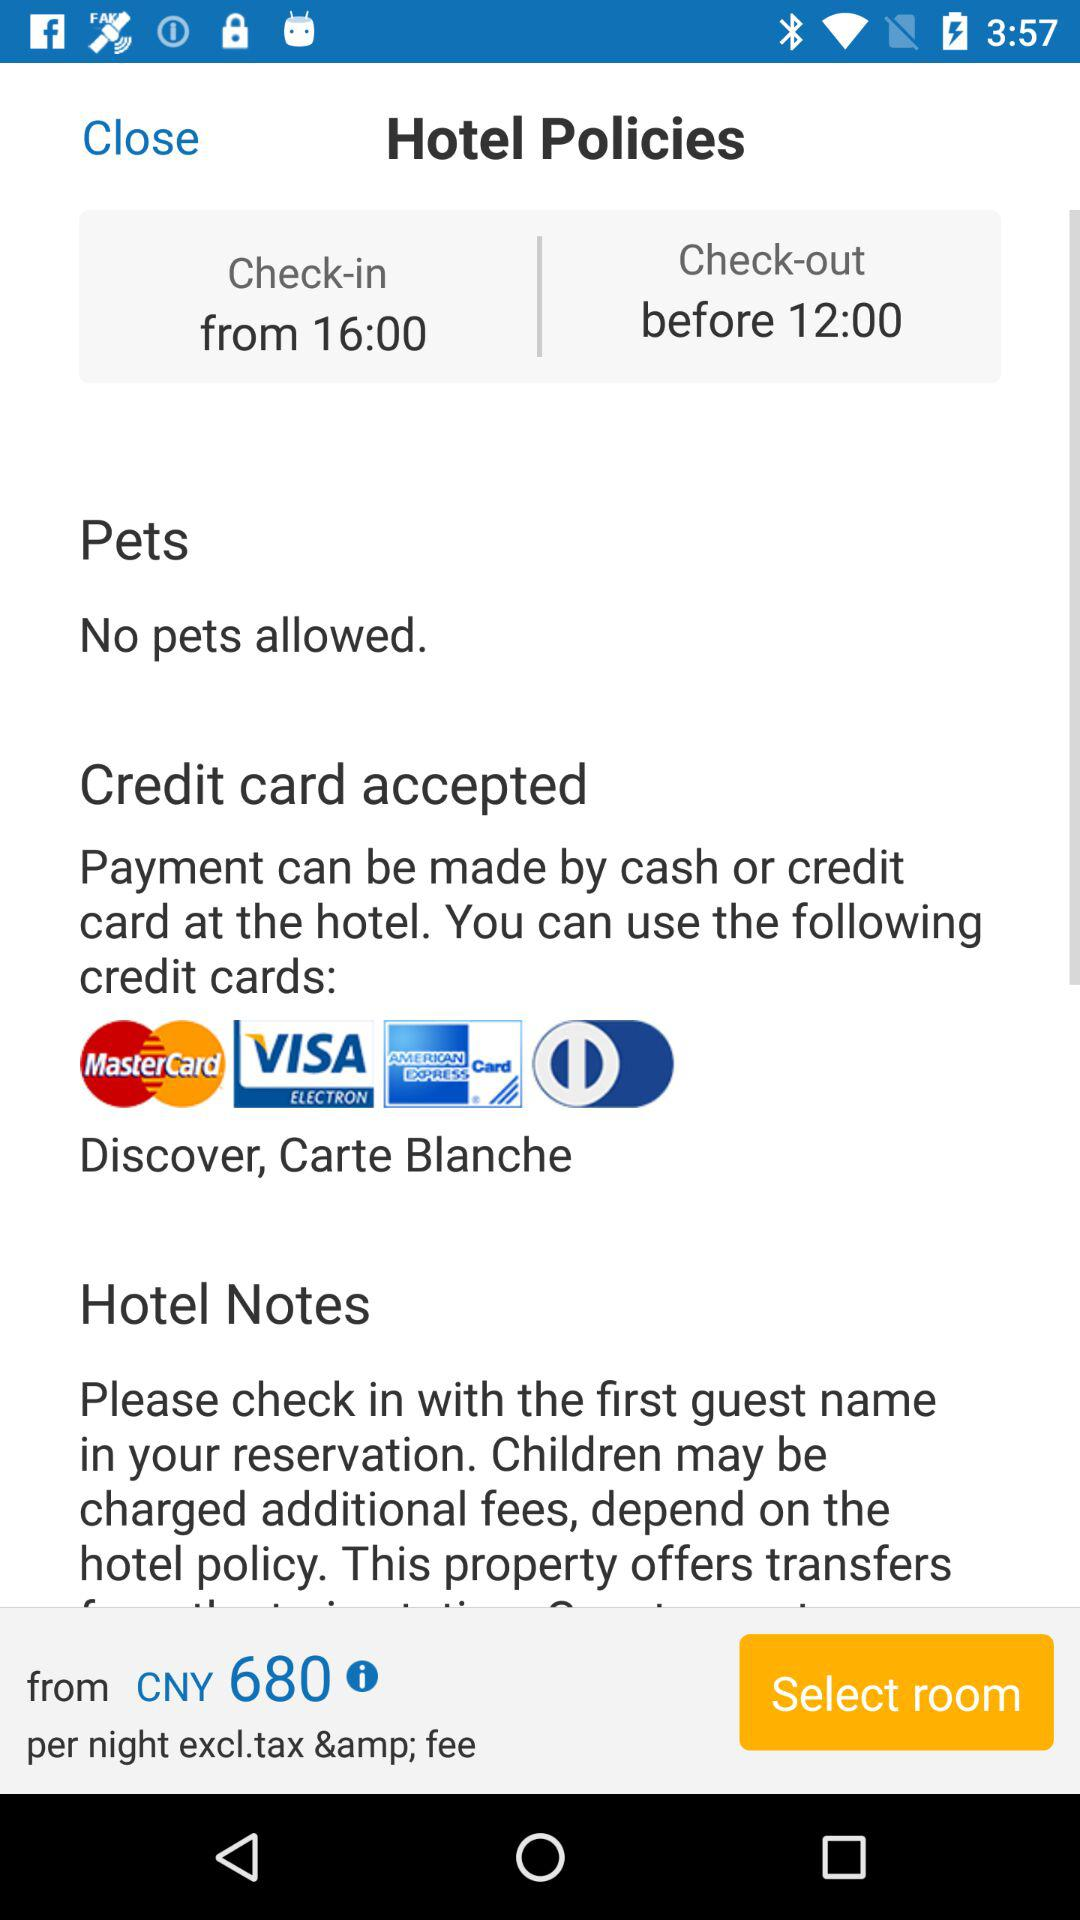What's the check-out time? The check-out time is before 12:00. 